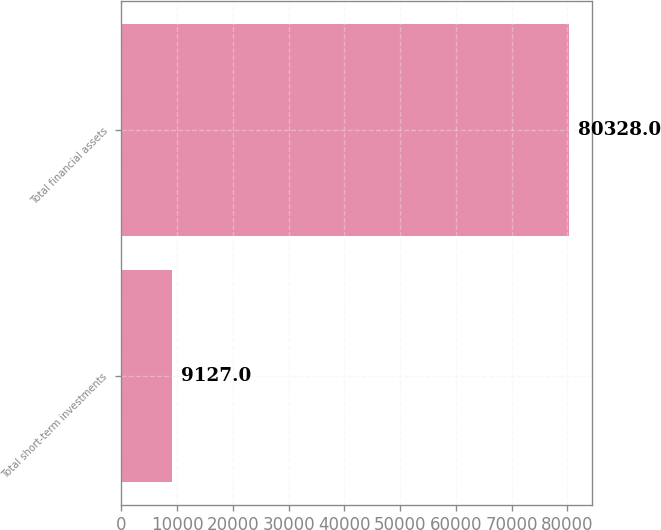Convert chart to OTSL. <chart><loc_0><loc_0><loc_500><loc_500><bar_chart><fcel>Total short-term investments<fcel>Total financial assets<nl><fcel>9127<fcel>80328<nl></chart> 